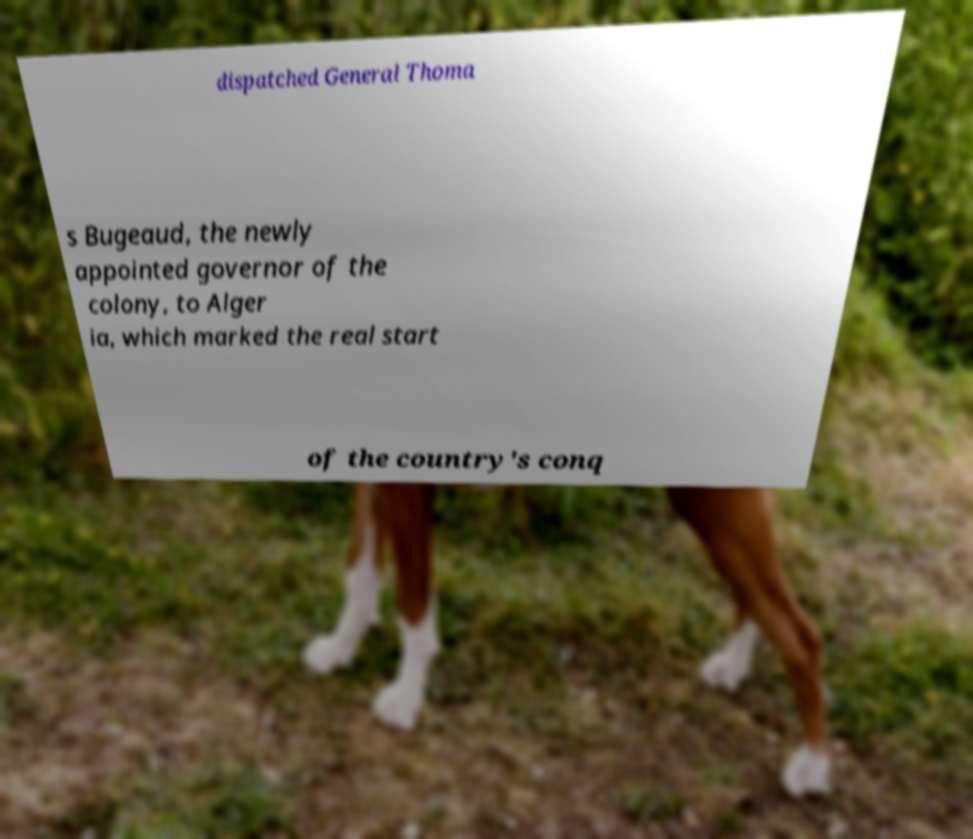Can you accurately transcribe the text from the provided image for me? dispatched General Thoma s Bugeaud, the newly appointed governor of the colony, to Alger ia, which marked the real start of the country's conq 